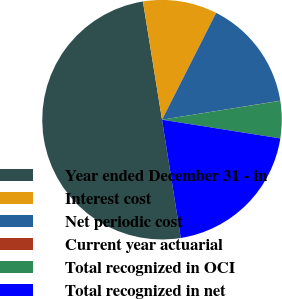Convert chart to OTSL. <chart><loc_0><loc_0><loc_500><loc_500><pie_chart><fcel>Year ended December 31 - in<fcel>Interest cost<fcel>Net periodic cost<fcel>Current year actuarial<fcel>Total recognized in OCI<fcel>Total recognized in net<nl><fcel>49.95%<fcel>10.01%<fcel>15.0%<fcel>0.02%<fcel>5.02%<fcel>20.0%<nl></chart> 